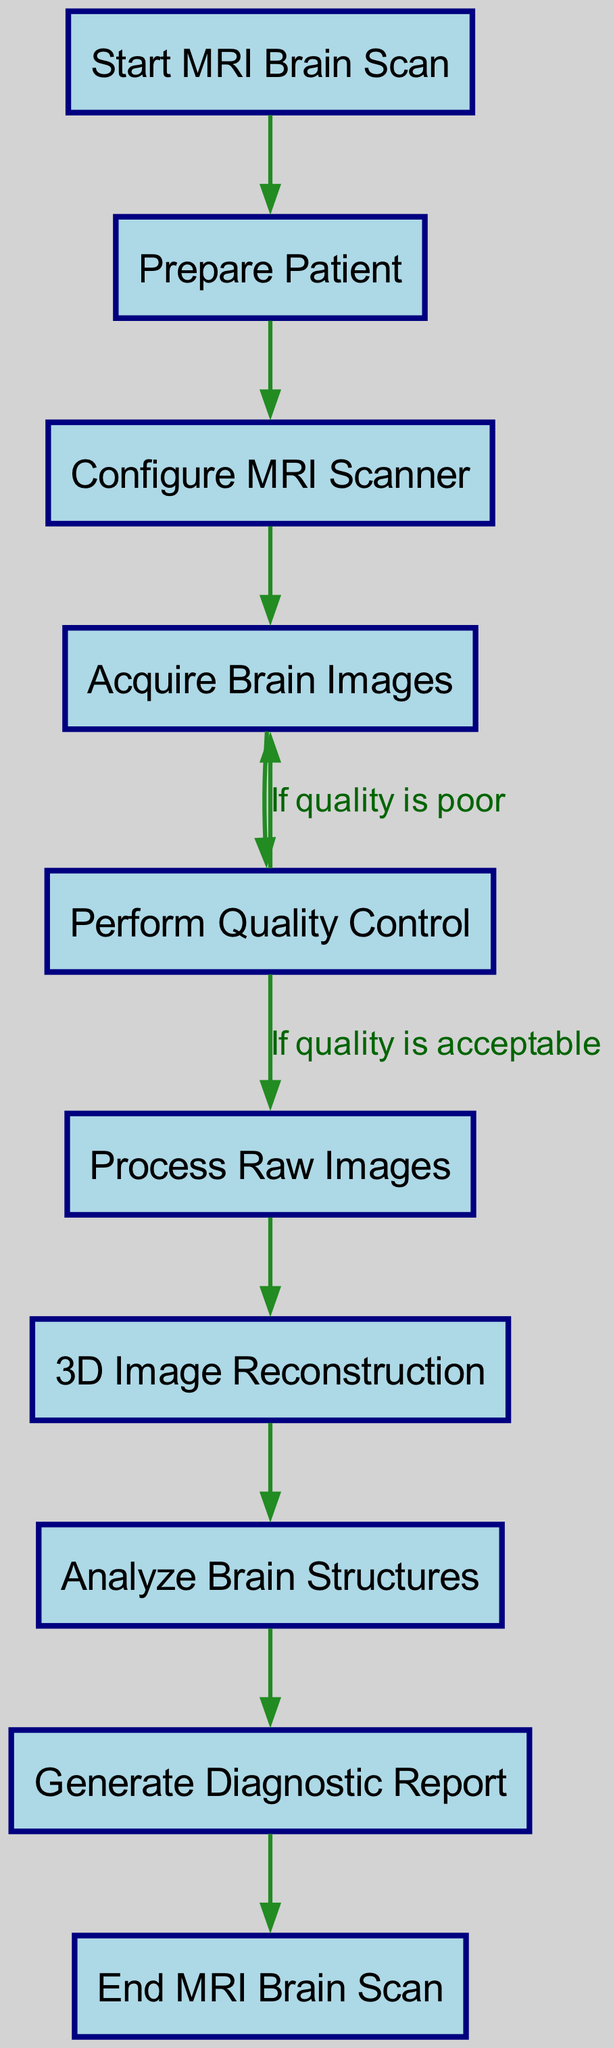What is the first step in the MRI brain scan workflow? The first node in the diagram indicates the initial action of the workflow, which is labeled as "Start MRI Brain Scan."
Answer: Start MRI Brain Scan How many nodes are in the workflow diagram? By counting the listed nodes in the diagram, there are ten distinct steps involved in the MRI brain scan workflow.
Answer: 10 What action occurs after acquiring brain images? Following the "Acquire Brain Images" step, the next action according to the flow is "Perform Quality Control."
Answer: Perform Quality Control What happens if the quality check is poor? The diagram shows that if the quality check is deemed poor, the workflow returns to the "Acquire Brain Images" step to try again.
Answer: Acquire Brain Images Which node generates the diagnostic report? The node responsible for generating the report is labeled as "Generate Diagnostic Report," which comes after analyzing brain structures.
Answer: Generate Diagnostic Report How many edges indicate a return to the previous step in the workflow? There is one edge drawn in the diagram that indicates a return, specifically from "Perform Quality Control" back to "Acquire Brain Images."
Answer: 1 What is the last action in the MRI brain scan workflow? The final node that concludes the workflow is labeled as "End MRI Brain Scan."
Answer: End MRI Brain Scan What is one action taken if the quality check is acceptable? If the quality check is acceptable, the workflow proceeds to the step called "Process Raw Images."
Answer: Process Raw Images In which step is 3D image reconstruction performed? The step for 3D image reconstruction in the workflow is indicated as "3D Image Reconstruction," following the processing of images.
Answer: 3D Image Reconstruction 